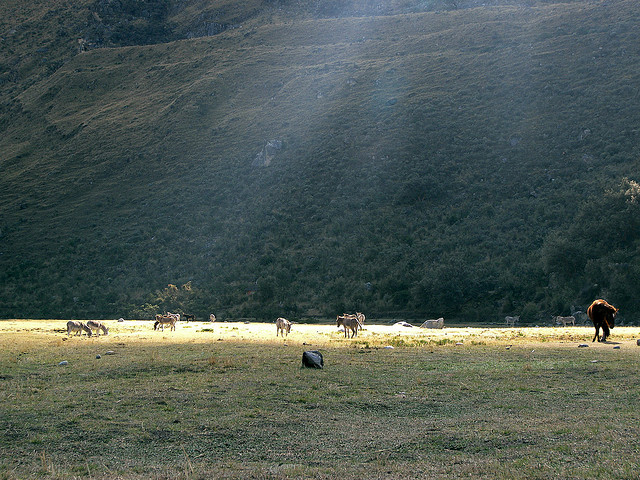How many chairs are in this room? The image does not depict a room but rather an outdoor scene with grazing animals and no chairs visible. 